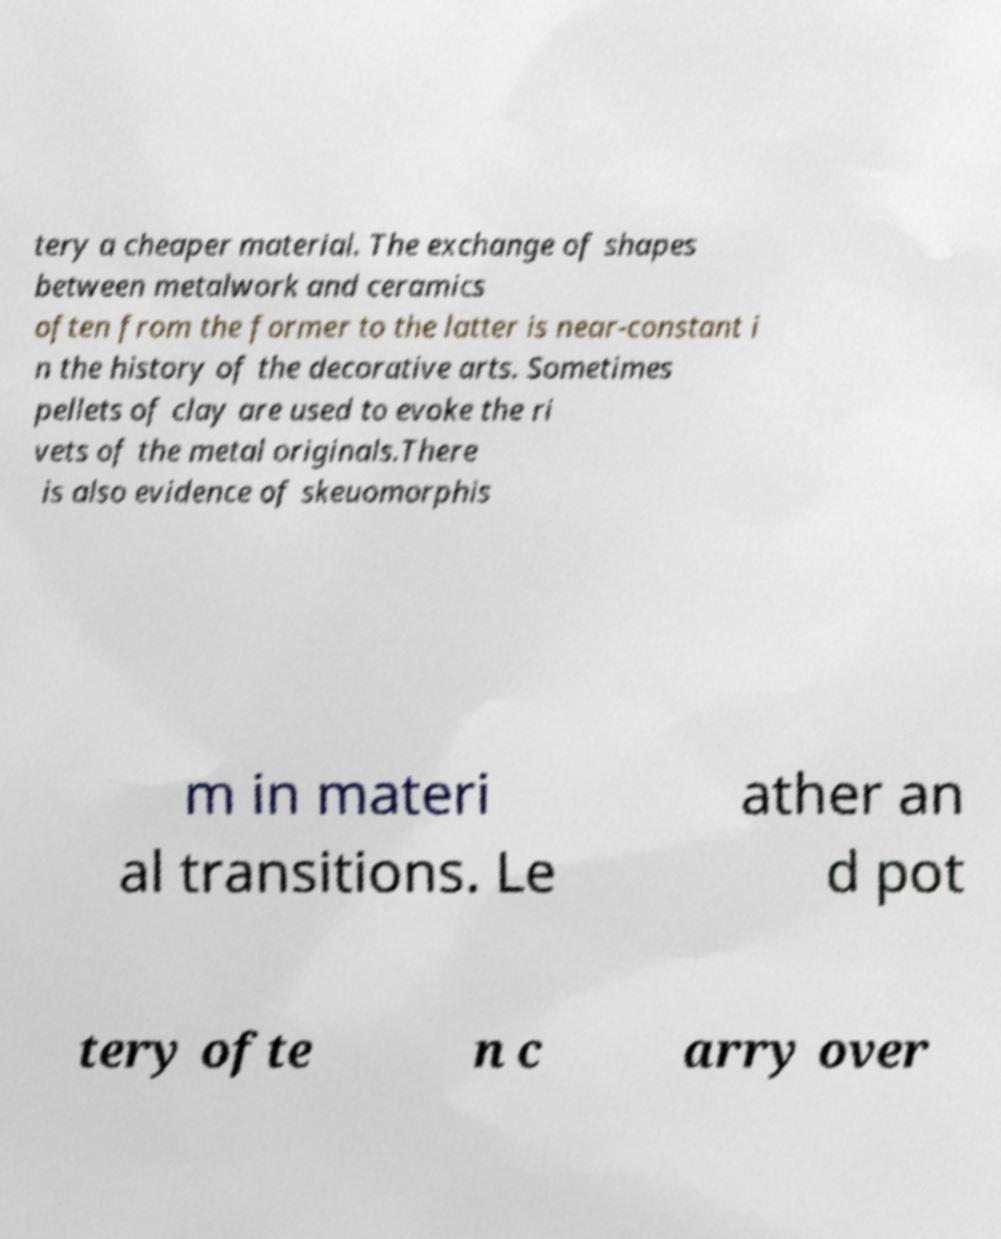Can you read and provide the text displayed in the image?This photo seems to have some interesting text. Can you extract and type it out for me? tery a cheaper material. The exchange of shapes between metalwork and ceramics often from the former to the latter is near-constant i n the history of the decorative arts. Sometimes pellets of clay are used to evoke the ri vets of the metal originals.There is also evidence of skeuomorphis m in materi al transitions. Le ather an d pot tery ofte n c arry over 